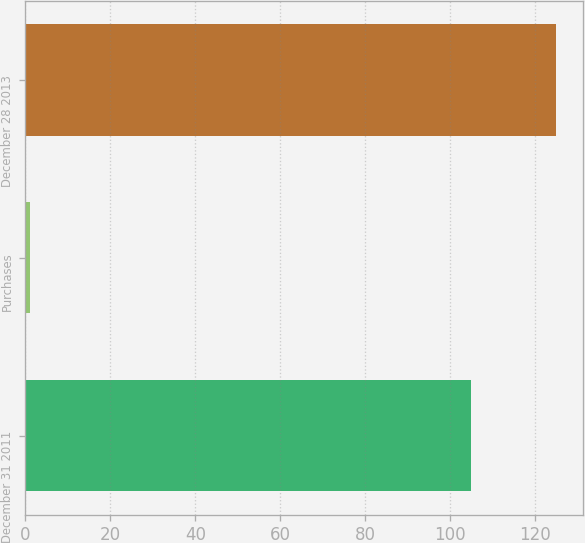Convert chart to OTSL. <chart><loc_0><loc_0><loc_500><loc_500><bar_chart><fcel>December 31 2011<fcel>Purchases<fcel>December 28 2013<nl><fcel>105<fcel>1<fcel>125<nl></chart> 